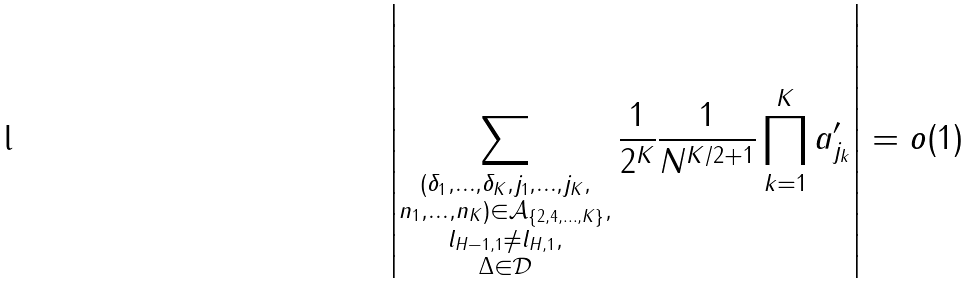Convert formula to latex. <formula><loc_0><loc_0><loc_500><loc_500>\left | \sum _ { \substack { ( \delta _ { 1 } , \dots , \delta _ { K } , j _ { 1 } , \dots , j _ { K } , \\ n _ { 1 } , \dots , n _ { K } ) \in \mathcal { A } _ { \{ 2 , 4 , \dots , K \} } , \\ l _ { H - 1 , 1 } \neq l _ { H , 1 } , \\ \Delta \in \mathcal { D } } } \frac { 1 } { 2 ^ { K } } \frac { 1 } { N ^ { K / 2 + 1 } } \prod _ { k = 1 } ^ { K } a ^ { \prime } _ { j _ { k } } \right | = o ( 1 )</formula> 